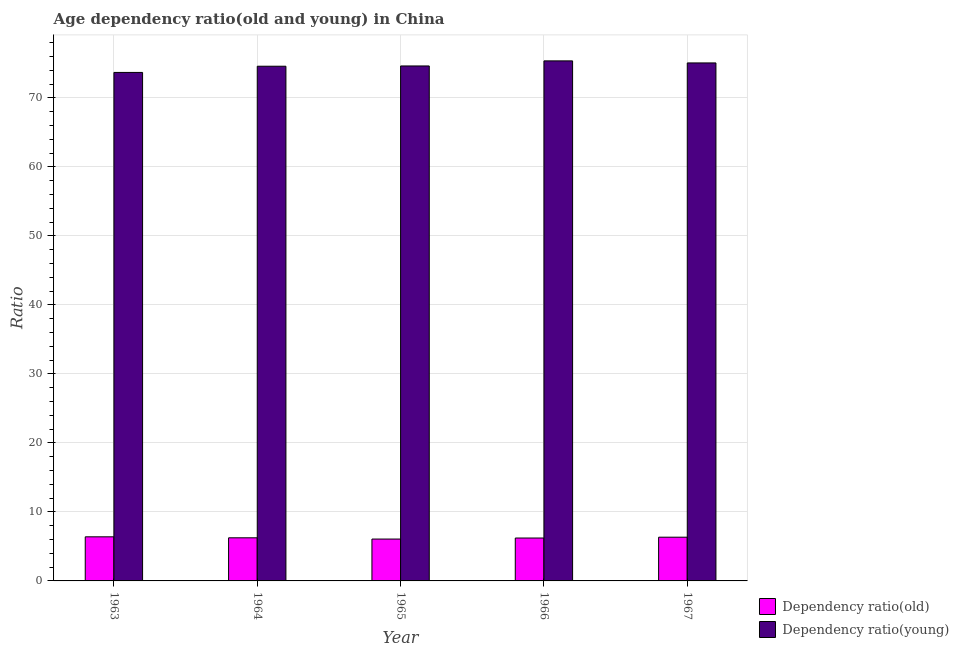How many different coloured bars are there?
Provide a succinct answer. 2. How many groups of bars are there?
Keep it short and to the point. 5. Are the number of bars on each tick of the X-axis equal?
Make the answer very short. Yes. What is the label of the 2nd group of bars from the left?
Offer a very short reply. 1964. What is the age dependency ratio(young) in 1966?
Give a very brief answer. 75.35. Across all years, what is the maximum age dependency ratio(young)?
Make the answer very short. 75.35. Across all years, what is the minimum age dependency ratio(old)?
Your answer should be compact. 6.07. What is the total age dependency ratio(young) in the graph?
Your answer should be very brief. 373.27. What is the difference between the age dependency ratio(old) in 1964 and that in 1965?
Provide a succinct answer. 0.18. What is the difference between the age dependency ratio(young) in 1963 and the age dependency ratio(old) in 1967?
Ensure brevity in your answer.  -1.38. What is the average age dependency ratio(young) per year?
Offer a terse response. 74.65. In how many years, is the age dependency ratio(old) greater than 20?
Ensure brevity in your answer.  0. What is the ratio of the age dependency ratio(old) in 1963 to that in 1964?
Provide a succinct answer. 1.02. Is the difference between the age dependency ratio(young) in 1965 and 1967 greater than the difference between the age dependency ratio(old) in 1965 and 1967?
Make the answer very short. No. What is the difference between the highest and the second highest age dependency ratio(young)?
Make the answer very short. 0.3. What is the difference between the highest and the lowest age dependency ratio(old)?
Make the answer very short. 0.32. In how many years, is the age dependency ratio(old) greater than the average age dependency ratio(old) taken over all years?
Provide a short and direct response. 2. What does the 2nd bar from the left in 1964 represents?
Make the answer very short. Dependency ratio(young). What does the 1st bar from the right in 1964 represents?
Keep it short and to the point. Dependency ratio(young). What is the difference between two consecutive major ticks on the Y-axis?
Make the answer very short. 10. Does the graph contain grids?
Your answer should be compact. Yes. Where does the legend appear in the graph?
Make the answer very short. Bottom right. What is the title of the graph?
Your answer should be very brief. Age dependency ratio(old and young) in China. Does "Researchers" appear as one of the legend labels in the graph?
Provide a short and direct response. No. What is the label or title of the Y-axis?
Your response must be concise. Ratio. What is the Ratio in Dependency ratio(old) in 1963?
Provide a short and direct response. 6.39. What is the Ratio of Dependency ratio(young) in 1963?
Provide a short and direct response. 73.68. What is the Ratio in Dependency ratio(old) in 1964?
Ensure brevity in your answer.  6.25. What is the Ratio of Dependency ratio(young) in 1964?
Make the answer very short. 74.58. What is the Ratio of Dependency ratio(old) in 1965?
Offer a very short reply. 6.07. What is the Ratio of Dependency ratio(young) in 1965?
Ensure brevity in your answer.  74.61. What is the Ratio in Dependency ratio(old) in 1966?
Your response must be concise. 6.21. What is the Ratio of Dependency ratio(young) in 1966?
Offer a very short reply. 75.35. What is the Ratio of Dependency ratio(old) in 1967?
Offer a very short reply. 6.34. What is the Ratio in Dependency ratio(young) in 1967?
Your answer should be very brief. 75.05. Across all years, what is the maximum Ratio of Dependency ratio(old)?
Provide a short and direct response. 6.39. Across all years, what is the maximum Ratio of Dependency ratio(young)?
Provide a short and direct response. 75.35. Across all years, what is the minimum Ratio of Dependency ratio(old)?
Give a very brief answer. 6.07. Across all years, what is the minimum Ratio of Dependency ratio(young)?
Offer a terse response. 73.68. What is the total Ratio in Dependency ratio(old) in the graph?
Provide a succinct answer. 31.26. What is the total Ratio of Dependency ratio(young) in the graph?
Offer a terse response. 373.27. What is the difference between the Ratio in Dependency ratio(old) in 1963 and that in 1964?
Make the answer very short. 0.14. What is the difference between the Ratio of Dependency ratio(young) in 1963 and that in 1964?
Make the answer very short. -0.9. What is the difference between the Ratio of Dependency ratio(old) in 1963 and that in 1965?
Make the answer very short. 0.32. What is the difference between the Ratio of Dependency ratio(young) in 1963 and that in 1965?
Your answer should be very brief. -0.94. What is the difference between the Ratio in Dependency ratio(old) in 1963 and that in 1966?
Provide a succinct answer. 0.17. What is the difference between the Ratio in Dependency ratio(young) in 1963 and that in 1966?
Offer a terse response. -1.67. What is the difference between the Ratio in Dependency ratio(old) in 1963 and that in 1967?
Your response must be concise. 0.05. What is the difference between the Ratio of Dependency ratio(young) in 1963 and that in 1967?
Offer a very short reply. -1.38. What is the difference between the Ratio in Dependency ratio(old) in 1964 and that in 1965?
Provide a short and direct response. 0.18. What is the difference between the Ratio of Dependency ratio(young) in 1964 and that in 1965?
Offer a terse response. -0.04. What is the difference between the Ratio in Dependency ratio(old) in 1964 and that in 1966?
Give a very brief answer. 0.03. What is the difference between the Ratio of Dependency ratio(young) in 1964 and that in 1966?
Offer a terse response. -0.77. What is the difference between the Ratio in Dependency ratio(old) in 1964 and that in 1967?
Provide a succinct answer. -0.09. What is the difference between the Ratio of Dependency ratio(young) in 1964 and that in 1967?
Keep it short and to the point. -0.48. What is the difference between the Ratio in Dependency ratio(old) in 1965 and that in 1966?
Your answer should be very brief. -0.15. What is the difference between the Ratio of Dependency ratio(young) in 1965 and that in 1966?
Your response must be concise. -0.74. What is the difference between the Ratio in Dependency ratio(old) in 1965 and that in 1967?
Make the answer very short. -0.27. What is the difference between the Ratio in Dependency ratio(young) in 1965 and that in 1967?
Offer a terse response. -0.44. What is the difference between the Ratio of Dependency ratio(old) in 1966 and that in 1967?
Provide a succinct answer. -0.12. What is the difference between the Ratio of Dependency ratio(young) in 1966 and that in 1967?
Your answer should be compact. 0.3. What is the difference between the Ratio in Dependency ratio(old) in 1963 and the Ratio in Dependency ratio(young) in 1964?
Keep it short and to the point. -68.19. What is the difference between the Ratio in Dependency ratio(old) in 1963 and the Ratio in Dependency ratio(young) in 1965?
Provide a succinct answer. -68.23. What is the difference between the Ratio in Dependency ratio(old) in 1963 and the Ratio in Dependency ratio(young) in 1966?
Make the answer very short. -68.96. What is the difference between the Ratio of Dependency ratio(old) in 1963 and the Ratio of Dependency ratio(young) in 1967?
Ensure brevity in your answer.  -68.66. What is the difference between the Ratio in Dependency ratio(old) in 1964 and the Ratio in Dependency ratio(young) in 1965?
Make the answer very short. -68.37. What is the difference between the Ratio of Dependency ratio(old) in 1964 and the Ratio of Dependency ratio(young) in 1966?
Offer a very short reply. -69.1. What is the difference between the Ratio of Dependency ratio(old) in 1964 and the Ratio of Dependency ratio(young) in 1967?
Provide a succinct answer. -68.81. What is the difference between the Ratio in Dependency ratio(old) in 1965 and the Ratio in Dependency ratio(young) in 1966?
Offer a very short reply. -69.28. What is the difference between the Ratio of Dependency ratio(old) in 1965 and the Ratio of Dependency ratio(young) in 1967?
Offer a very short reply. -68.99. What is the difference between the Ratio of Dependency ratio(old) in 1966 and the Ratio of Dependency ratio(young) in 1967?
Provide a short and direct response. -68.84. What is the average Ratio of Dependency ratio(old) per year?
Offer a very short reply. 6.25. What is the average Ratio in Dependency ratio(young) per year?
Your answer should be very brief. 74.65. In the year 1963, what is the difference between the Ratio in Dependency ratio(old) and Ratio in Dependency ratio(young)?
Offer a terse response. -67.29. In the year 1964, what is the difference between the Ratio of Dependency ratio(old) and Ratio of Dependency ratio(young)?
Make the answer very short. -68.33. In the year 1965, what is the difference between the Ratio of Dependency ratio(old) and Ratio of Dependency ratio(young)?
Your response must be concise. -68.55. In the year 1966, what is the difference between the Ratio in Dependency ratio(old) and Ratio in Dependency ratio(young)?
Your answer should be compact. -69.14. In the year 1967, what is the difference between the Ratio in Dependency ratio(old) and Ratio in Dependency ratio(young)?
Your response must be concise. -68.72. What is the ratio of the Ratio in Dependency ratio(old) in 1963 to that in 1964?
Give a very brief answer. 1.02. What is the ratio of the Ratio of Dependency ratio(young) in 1963 to that in 1964?
Your answer should be compact. 0.99. What is the ratio of the Ratio in Dependency ratio(old) in 1963 to that in 1965?
Your response must be concise. 1.05. What is the ratio of the Ratio of Dependency ratio(young) in 1963 to that in 1965?
Ensure brevity in your answer.  0.99. What is the ratio of the Ratio in Dependency ratio(old) in 1963 to that in 1966?
Offer a very short reply. 1.03. What is the ratio of the Ratio in Dependency ratio(young) in 1963 to that in 1966?
Make the answer very short. 0.98. What is the ratio of the Ratio in Dependency ratio(old) in 1963 to that in 1967?
Your answer should be very brief. 1.01. What is the ratio of the Ratio in Dependency ratio(young) in 1963 to that in 1967?
Provide a succinct answer. 0.98. What is the ratio of the Ratio in Dependency ratio(old) in 1964 to that in 1965?
Keep it short and to the point. 1.03. What is the ratio of the Ratio of Dependency ratio(young) in 1964 to that in 1966?
Provide a succinct answer. 0.99. What is the ratio of the Ratio of Dependency ratio(old) in 1964 to that in 1967?
Give a very brief answer. 0.99. What is the ratio of the Ratio of Dependency ratio(old) in 1965 to that in 1966?
Ensure brevity in your answer.  0.98. What is the ratio of the Ratio in Dependency ratio(young) in 1965 to that in 1966?
Provide a succinct answer. 0.99. What is the ratio of the Ratio in Dependency ratio(old) in 1965 to that in 1967?
Offer a very short reply. 0.96. What is the ratio of the Ratio in Dependency ratio(young) in 1965 to that in 1967?
Your answer should be compact. 0.99. What is the ratio of the Ratio in Dependency ratio(old) in 1966 to that in 1967?
Provide a short and direct response. 0.98. What is the difference between the highest and the second highest Ratio in Dependency ratio(old)?
Offer a very short reply. 0.05. What is the difference between the highest and the second highest Ratio of Dependency ratio(young)?
Offer a very short reply. 0.3. What is the difference between the highest and the lowest Ratio in Dependency ratio(old)?
Make the answer very short. 0.32. What is the difference between the highest and the lowest Ratio of Dependency ratio(young)?
Your answer should be very brief. 1.67. 